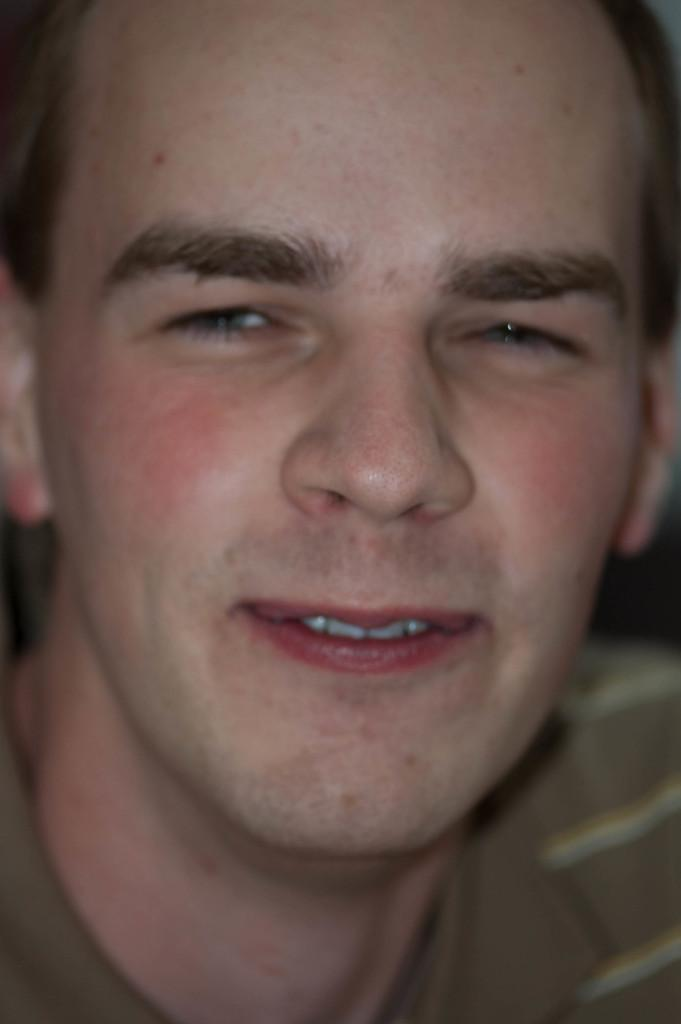What is present in the image? There is a person in the image. Can you describe the person's facial expression? The person's face is visible, and they are smiling. How many pigs are visible in the image? There are no pigs present in the image; it features a person with a visible smile. Why is the person crying in the image? The person is not crying in the image; they are smiling. 